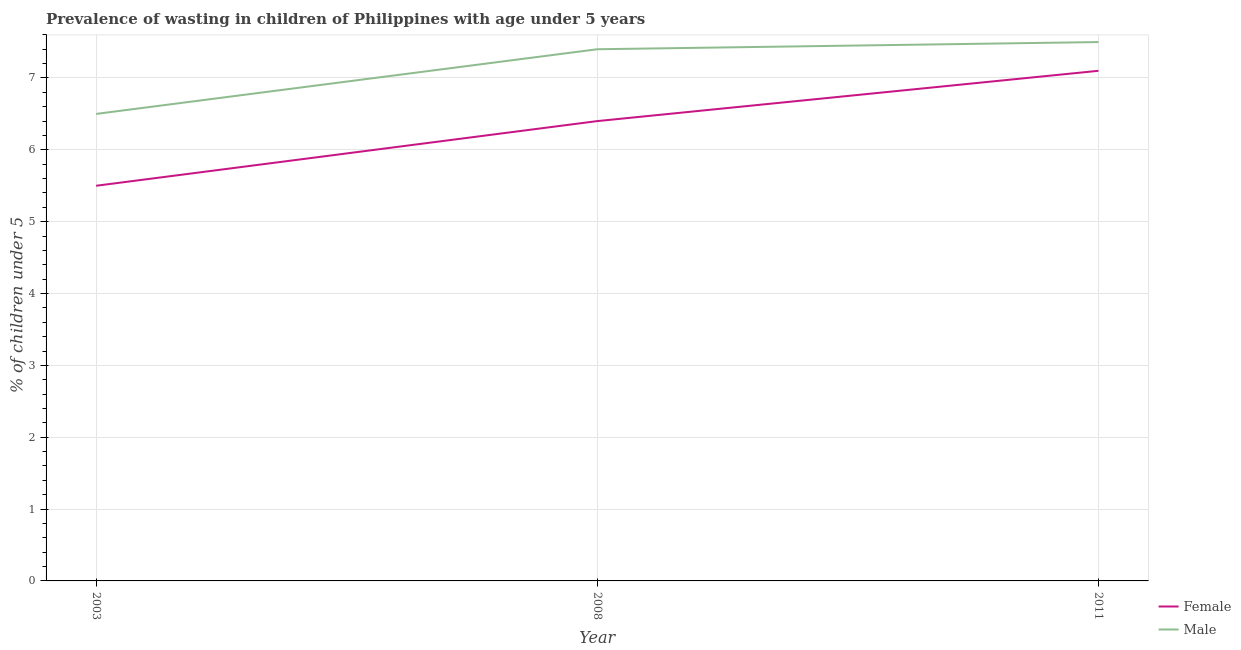How many different coloured lines are there?
Your response must be concise. 2. Does the line corresponding to percentage of undernourished male children intersect with the line corresponding to percentage of undernourished female children?
Your answer should be compact. No. Is the number of lines equal to the number of legend labels?
Your answer should be very brief. Yes. Across all years, what is the maximum percentage of undernourished male children?
Keep it short and to the point. 7.5. Across all years, what is the minimum percentage of undernourished female children?
Provide a short and direct response. 5.5. In which year was the percentage of undernourished male children maximum?
Your answer should be compact. 2011. In which year was the percentage of undernourished female children minimum?
Your response must be concise. 2003. What is the total percentage of undernourished female children in the graph?
Offer a terse response. 19. What is the difference between the percentage of undernourished female children in 2008 and that in 2011?
Offer a terse response. -0.7. What is the difference between the percentage of undernourished female children in 2011 and the percentage of undernourished male children in 2003?
Offer a very short reply. 0.6. What is the average percentage of undernourished male children per year?
Provide a succinct answer. 7.13. In how many years, is the percentage of undernourished male children greater than 0.6000000000000001 %?
Offer a terse response. 3. What is the ratio of the percentage of undernourished female children in 2003 to that in 2008?
Your response must be concise. 0.86. Is the percentage of undernourished male children in 2003 less than that in 2008?
Your response must be concise. Yes. Is the difference between the percentage of undernourished female children in 2008 and 2011 greater than the difference between the percentage of undernourished male children in 2008 and 2011?
Offer a very short reply. No. What is the difference between the highest and the second highest percentage of undernourished male children?
Make the answer very short. 0.1. What is the difference between the highest and the lowest percentage of undernourished male children?
Offer a very short reply. 1. In how many years, is the percentage of undernourished female children greater than the average percentage of undernourished female children taken over all years?
Offer a terse response. 2. Is the sum of the percentage of undernourished female children in 2008 and 2011 greater than the maximum percentage of undernourished male children across all years?
Your answer should be very brief. Yes. Does the percentage of undernourished female children monotonically increase over the years?
Provide a short and direct response. Yes. Is the percentage of undernourished male children strictly greater than the percentage of undernourished female children over the years?
Your answer should be very brief. Yes. How many years are there in the graph?
Keep it short and to the point. 3. Are the values on the major ticks of Y-axis written in scientific E-notation?
Your answer should be very brief. No. How many legend labels are there?
Provide a short and direct response. 2. What is the title of the graph?
Keep it short and to the point. Prevalence of wasting in children of Philippines with age under 5 years. Does "Official aid received" appear as one of the legend labels in the graph?
Your response must be concise. No. What is the label or title of the Y-axis?
Make the answer very short.  % of children under 5. What is the  % of children under 5 of Female in 2008?
Offer a terse response. 6.4. What is the  % of children under 5 in Male in 2008?
Offer a terse response. 7.4. What is the  % of children under 5 in Female in 2011?
Give a very brief answer. 7.1. What is the  % of children under 5 in Male in 2011?
Provide a succinct answer. 7.5. Across all years, what is the maximum  % of children under 5 of Female?
Your response must be concise. 7.1. Across all years, what is the minimum  % of children under 5 of Female?
Provide a succinct answer. 5.5. What is the total  % of children under 5 of Female in the graph?
Give a very brief answer. 19. What is the total  % of children under 5 of Male in the graph?
Ensure brevity in your answer.  21.4. What is the difference between the  % of children under 5 of Female in 2003 and that in 2008?
Make the answer very short. -0.9. What is the difference between the  % of children under 5 in Female in 2003 and that in 2011?
Keep it short and to the point. -1.6. What is the difference between the  % of children under 5 of Male in 2003 and that in 2011?
Your response must be concise. -1. What is the difference between the  % of children under 5 of Female in 2003 and the  % of children under 5 of Male in 2011?
Keep it short and to the point. -2. What is the difference between the  % of children under 5 of Female in 2008 and the  % of children under 5 of Male in 2011?
Keep it short and to the point. -1.1. What is the average  % of children under 5 in Female per year?
Offer a terse response. 6.33. What is the average  % of children under 5 in Male per year?
Offer a terse response. 7.13. In the year 2008, what is the difference between the  % of children under 5 of Female and  % of children under 5 of Male?
Make the answer very short. -1. What is the ratio of the  % of children under 5 in Female in 2003 to that in 2008?
Make the answer very short. 0.86. What is the ratio of the  % of children under 5 in Male in 2003 to that in 2008?
Offer a very short reply. 0.88. What is the ratio of the  % of children under 5 in Female in 2003 to that in 2011?
Provide a succinct answer. 0.77. What is the ratio of the  % of children under 5 of Male in 2003 to that in 2011?
Provide a short and direct response. 0.87. What is the ratio of the  % of children under 5 of Female in 2008 to that in 2011?
Make the answer very short. 0.9. What is the ratio of the  % of children under 5 in Male in 2008 to that in 2011?
Offer a terse response. 0.99. What is the difference between the highest and the second highest  % of children under 5 in Female?
Ensure brevity in your answer.  0.7. What is the difference between the highest and the second highest  % of children under 5 in Male?
Offer a terse response. 0.1. 